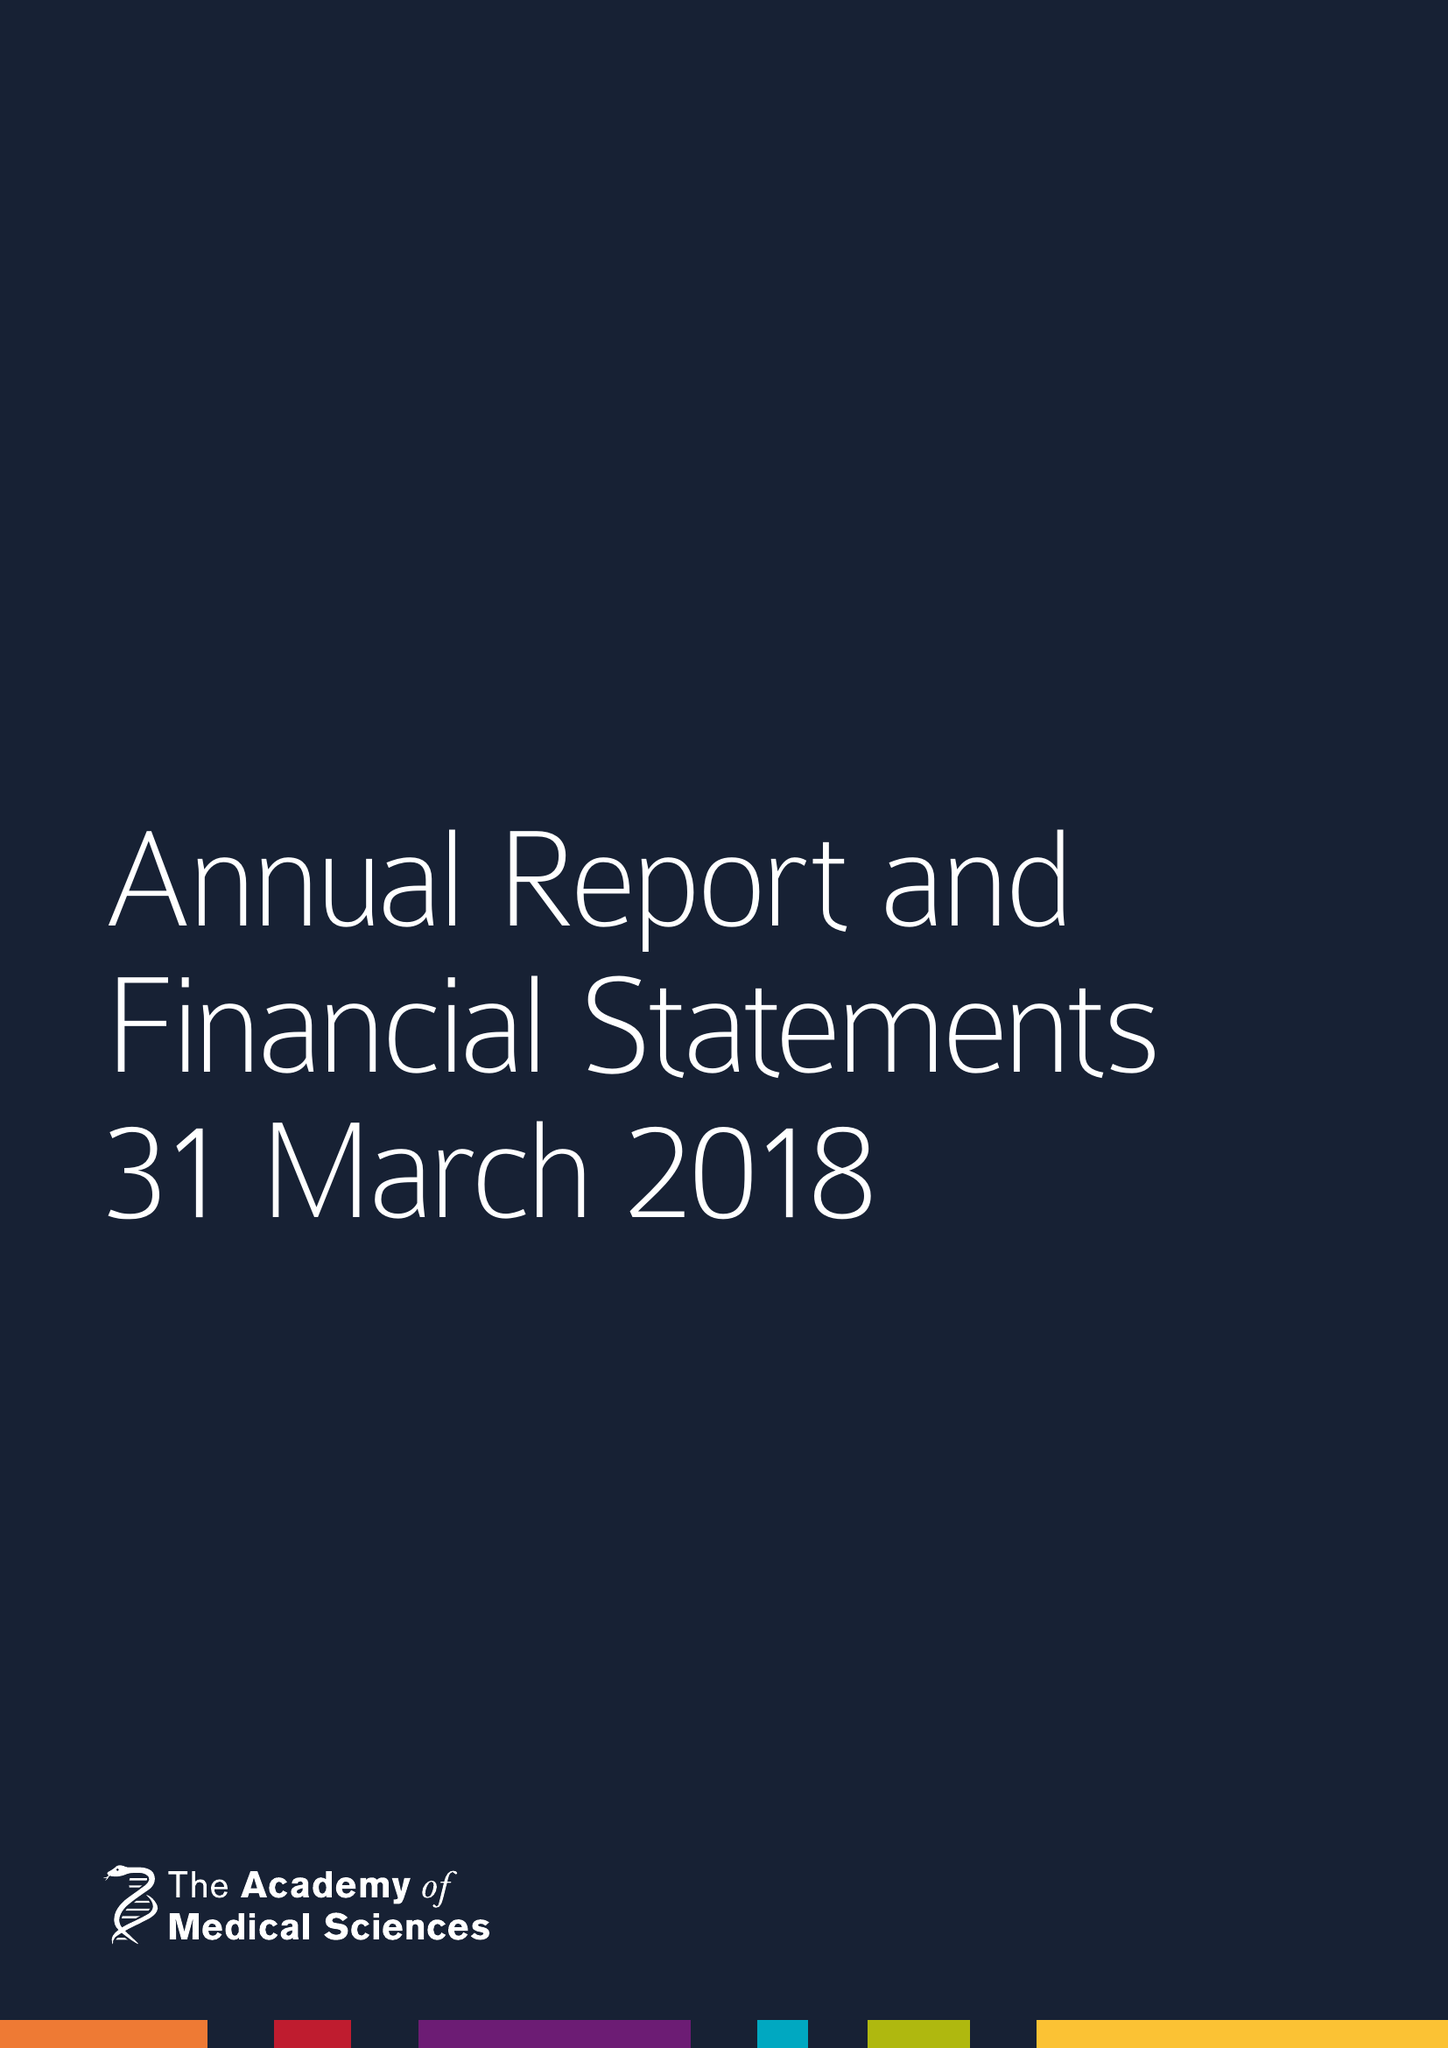What is the value for the income_annually_in_british_pounds?
Answer the question using a single word or phrase. 11848796.00 